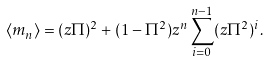<formula> <loc_0><loc_0><loc_500><loc_500>\langle m _ { n } \rangle = ( z \Pi ) ^ { 2 } + ( 1 - \Pi ^ { 2 } ) z ^ { n } \sum _ { i = 0 } ^ { n - 1 } ( z \Pi ^ { 2 } ) ^ { i } .</formula> 